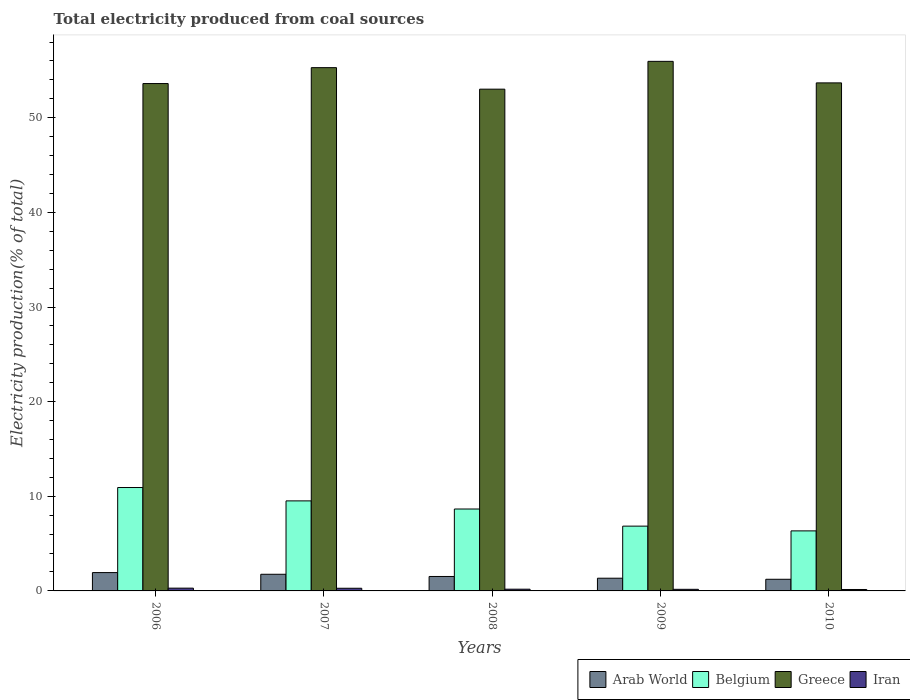How many different coloured bars are there?
Your answer should be very brief. 4. How many groups of bars are there?
Your response must be concise. 5. Are the number of bars per tick equal to the number of legend labels?
Provide a succinct answer. Yes. How many bars are there on the 4th tick from the left?
Your answer should be compact. 4. How many bars are there on the 5th tick from the right?
Ensure brevity in your answer.  4. What is the label of the 3rd group of bars from the left?
Give a very brief answer. 2008. In how many cases, is the number of bars for a given year not equal to the number of legend labels?
Keep it short and to the point. 0. What is the total electricity produced in Iran in 2006?
Offer a terse response. 0.29. Across all years, what is the maximum total electricity produced in Iran?
Provide a succinct answer. 0.29. Across all years, what is the minimum total electricity produced in Iran?
Offer a terse response. 0.15. In which year was the total electricity produced in Iran maximum?
Provide a succinct answer. 2006. What is the total total electricity produced in Greece in the graph?
Make the answer very short. 271.57. What is the difference between the total electricity produced in Arab World in 2007 and that in 2009?
Your response must be concise. 0.42. What is the difference between the total electricity produced in Arab World in 2008 and the total electricity produced in Iran in 2009?
Provide a succinct answer. 1.36. What is the average total electricity produced in Iran per year?
Ensure brevity in your answer.  0.22. In the year 2010, what is the difference between the total electricity produced in Iran and total electricity produced in Greece?
Offer a very short reply. -53.53. What is the ratio of the total electricity produced in Iran in 2008 to that in 2009?
Your answer should be very brief. 1.07. What is the difference between the highest and the second highest total electricity produced in Arab World?
Make the answer very short. 0.18. What is the difference between the highest and the lowest total electricity produced in Iran?
Your response must be concise. 0.14. Is the sum of the total electricity produced in Arab World in 2007 and 2010 greater than the maximum total electricity produced in Belgium across all years?
Provide a succinct answer. No. What does the 3rd bar from the right in 2008 represents?
Offer a terse response. Belgium. Is it the case that in every year, the sum of the total electricity produced in Iran and total electricity produced in Arab World is greater than the total electricity produced in Belgium?
Make the answer very short. No. How many years are there in the graph?
Offer a very short reply. 5. Are the values on the major ticks of Y-axis written in scientific E-notation?
Your answer should be compact. No. Does the graph contain grids?
Keep it short and to the point. No. How many legend labels are there?
Offer a terse response. 4. How are the legend labels stacked?
Provide a succinct answer. Horizontal. What is the title of the graph?
Your answer should be compact. Total electricity produced from coal sources. Does "Least developed countries" appear as one of the legend labels in the graph?
Provide a short and direct response. No. What is the label or title of the X-axis?
Provide a short and direct response. Years. What is the Electricity production(% of total) in Arab World in 2006?
Provide a succinct answer. 1.94. What is the Electricity production(% of total) of Belgium in 2006?
Offer a terse response. 10.93. What is the Electricity production(% of total) of Greece in 2006?
Give a very brief answer. 53.61. What is the Electricity production(% of total) of Iran in 2006?
Offer a very short reply. 0.29. What is the Electricity production(% of total) of Arab World in 2007?
Offer a very short reply. 1.76. What is the Electricity production(% of total) of Belgium in 2007?
Give a very brief answer. 9.51. What is the Electricity production(% of total) in Greece in 2007?
Provide a short and direct response. 55.29. What is the Electricity production(% of total) in Iran in 2007?
Your answer should be very brief. 0.28. What is the Electricity production(% of total) of Arab World in 2008?
Provide a short and direct response. 1.53. What is the Electricity production(% of total) in Belgium in 2008?
Keep it short and to the point. 8.66. What is the Electricity production(% of total) of Greece in 2008?
Offer a terse response. 53.02. What is the Electricity production(% of total) in Iran in 2008?
Make the answer very short. 0.18. What is the Electricity production(% of total) in Arab World in 2009?
Provide a short and direct response. 1.34. What is the Electricity production(% of total) in Belgium in 2009?
Keep it short and to the point. 6.85. What is the Electricity production(% of total) in Greece in 2009?
Your answer should be compact. 55.96. What is the Electricity production(% of total) of Iran in 2009?
Keep it short and to the point. 0.17. What is the Electricity production(% of total) of Arab World in 2010?
Make the answer very short. 1.23. What is the Electricity production(% of total) in Belgium in 2010?
Offer a terse response. 6.34. What is the Electricity production(% of total) of Greece in 2010?
Your answer should be very brief. 53.68. What is the Electricity production(% of total) of Iran in 2010?
Keep it short and to the point. 0.15. Across all years, what is the maximum Electricity production(% of total) of Arab World?
Ensure brevity in your answer.  1.94. Across all years, what is the maximum Electricity production(% of total) in Belgium?
Keep it short and to the point. 10.93. Across all years, what is the maximum Electricity production(% of total) in Greece?
Ensure brevity in your answer.  55.96. Across all years, what is the maximum Electricity production(% of total) of Iran?
Ensure brevity in your answer.  0.29. Across all years, what is the minimum Electricity production(% of total) of Arab World?
Make the answer very short. 1.23. Across all years, what is the minimum Electricity production(% of total) in Belgium?
Make the answer very short. 6.34. Across all years, what is the minimum Electricity production(% of total) in Greece?
Make the answer very short. 53.02. Across all years, what is the minimum Electricity production(% of total) in Iran?
Your answer should be compact. 0.15. What is the total Electricity production(% of total) in Arab World in the graph?
Provide a succinct answer. 7.8. What is the total Electricity production(% of total) in Belgium in the graph?
Keep it short and to the point. 42.29. What is the total Electricity production(% of total) of Greece in the graph?
Ensure brevity in your answer.  271.57. What is the total Electricity production(% of total) in Iran in the graph?
Offer a terse response. 1.08. What is the difference between the Electricity production(% of total) of Arab World in 2006 and that in 2007?
Provide a short and direct response. 0.18. What is the difference between the Electricity production(% of total) of Belgium in 2006 and that in 2007?
Provide a short and direct response. 1.41. What is the difference between the Electricity production(% of total) of Greece in 2006 and that in 2007?
Keep it short and to the point. -1.68. What is the difference between the Electricity production(% of total) in Iran in 2006 and that in 2007?
Offer a very short reply. 0.01. What is the difference between the Electricity production(% of total) of Arab World in 2006 and that in 2008?
Ensure brevity in your answer.  0.41. What is the difference between the Electricity production(% of total) of Belgium in 2006 and that in 2008?
Your answer should be compact. 2.27. What is the difference between the Electricity production(% of total) of Greece in 2006 and that in 2008?
Give a very brief answer. 0.59. What is the difference between the Electricity production(% of total) in Iran in 2006 and that in 2008?
Ensure brevity in your answer.  0.11. What is the difference between the Electricity production(% of total) of Arab World in 2006 and that in 2009?
Make the answer very short. 0.59. What is the difference between the Electricity production(% of total) in Belgium in 2006 and that in 2009?
Your answer should be compact. 4.08. What is the difference between the Electricity production(% of total) of Greece in 2006 and that in 2009?
Ensure brevity in your answer.  -2.35. What is the difference between the Electricity production(% of total) of Iran in 2006 and that in 2009?
Make the answer very short. 0.12. What is the difference between the Electricity production(% of total) of Arab World in 2006 and that in 2010?
Offer a terse response. 0.71. What is the difference between the Electricity production(% of total) in Belgium in 2006 and that in 2010?
Your answer should be very brief. 4.58. What is the difference between the Electricity production(% of total) of Greece in 2006 and that in 2010?
Provide a succinct answer. -0.07. What is the difference between the Electricity production(% of total) in Iran in 2006 and that in 2010?
Provide a short and direct response. 0.14. What is the difference between the Electricity production(% of total) in Arab World in 2007 and that in 2008?
Your answer should be compact. 0.23. What is the difference between the Electricity production(% of total) of Belgium in 2007 and that in 2008?
Make the answer very short. 0.86. What is the difference between the Electricity production(% of total) of Greece in 2007 and that in 2008?
Keep it short and to the point. 2.27. What is the difference between the Electricity production(% of total) in Iran in 2007 and that in 2008?
Give a very brief answer. 0.1. What is the difference between the Electricity production(% of total) of Arab World in 2007 and that in 2009?
Make the answer very short. 0.42. What is the difference between the Electricity production(% of total) in Belgium in 2007 and that in 2009?
Make the answer very short. 2.67. What is the difference between the Electricity production(% of total) of Greece in 2007 and that in 2009?
Offer a very short reply. -0.66. What is the difference between the Electricity production(% of total) of Iran in 2007 and that in 2009?
Provide a short and direct response. 0.11. What is the difference between the Electricity production(% of total) of Arab World in 2007 and that in 2010?
Provide a succinct answer. 0.53. What is the difference between the Electricity production(% of total) of Belgium in 2007 and that in 2010?
Your answer should be compact. 3.17. What is the difference between the Electricity production(% of total) of Greece in 2007 and that in 2010?
Make the answer very short. 1.61. What is the difference between the Electricity production(% of total) of Iran in 2007 and that in 2010?
Provide a succinct answer. 0.13. What is the difference between the Electricity production(% of total) in Arab World in 2008 and that in 2009?
Give a very brief answer. 0.18. What is the difference between the Electricity production(% of total) of Belgium in 2008 and that in 2009?
Offer a terse response. 1.81. What is the difference between the Electricity production(% of total) in Greece in 2008 and that in 2009?
Provide a succinct answer. -2.94. What is the difference between the Electricity production(% of total) in Iran in 2008 and that in 2009?
Provide a succinct answer. 0.01. What is the difference between the Electricity production(% of total) of Arab World in 2008 and that in 2010?
Your response must be concise. 0.3. What is the difference between the Electricity production(% of total) in Belgium in 2008 and that in 2010?
Make the answer very short. 2.31. What is the difference between the Electricity production(% of total) in Greece in 2008 and that in 2010?
Provide a succinct answer. -0.66. What is the difference between the Electricity production(% of total) in Iran in 2008 and that in 2010?
Offer a terse response. 0.03. What is the difference between the Electricity production(% of total) in Arab World in 2009 and that in 2010?
Make the answer very short. 0.11. What is the difference between the Electricity production(% of total) in Belgium in 2009 and that in 2010?
Give a very brief answer. 0.5. What is the difference between the Electricity production(% of total) in Greece in 2009 and that in 2010?
Offer a very short reply. 2.28. What is the difference between the Electricity production(% of total) of Iran in 2009 and that in 2010?
Your answer should be very brief. 0.02. What is the difference between the Electricity production(% of total) in Arab World in 2006 and the Electricity production(% of total) in Belgium in 2007?
Your answer should be compact. -7.58. What is the difference between the Electricity production(% of total) of Arab World in 2006 and the Electricity production(% of total) of Greece in 2007?
Your response must be concise. -53.36. What is the difference between the Electricity production(% of total) in Arab World in 2006 and the Electricity production(% of total) in Iran in 2007?
Make the answer very short. 1.66. What is the difference between the Electricity production(% of total) of Belgium in 2006 and the Electricity production(% of total) of Greece in 2007?
Your response must be concise. -44.37. What is the difference between the Electricity production(% of total) of Belgium in 2006 and the Electricity production(% of total) of Iran in 2007?
Offer a very short reply. 10.64. What is the difference between the Electricity production(% of total) in Greece in 2006 and the Electricity production(% of total) in Iran in 2007?
Provide a succinct answer. 53.33. What is the difference between the Electricity production(% of total) of Arab World in 2006 and the Electricity production(% of total) of Belgium in 2008?
Your answer should be compact. -6.72. What is the difference between the Electricity production(% of total) in Arab World in 2006 and the Electricity production(% of total) in Greece in 2008?
Give a very brief answer. -51.08. What is the difference between the Electricity production(% of total) of Arab World in 2006 and the Electricity production(% of total) of Iran in 2008?
Make the answer very short. 1.76. What is the difference between the Electricity production(% of total) of Belgium in 2006 and the Electricity production(% of total) of Greece in 2008?
Offer a terse response. -42.09. What is the difference between the Electricity production(% of total) in Belgium in 2006 and the Electricity production(% of total) in Iran in 2008?
Your response must be concise. 10.74. What is the difference between the Electricity production(% of total) in Greece in 2006 and the Electricity production(% of total) in Iran in 2008?
Provide a short and direct response. 53.43. What is the difference between the Electricity production(% of total) of Arab World in 2006 and the Electricity production(% of total) of Belgium in 2009?
Your answer should be compact. -4.91. What is the difference between the Electricity production(% of total) in Arab World in 2006 and the Electricity production(% of total) in Greece in 2009?
Your response must be concise. -54.02. What is the difference between the Electricity production(% of total) of Arab World in 2006 and the Electricity production(% of total) of Iran in 2009?
Give a very brief answer. 1.77. What is the difference between the Electricity production(% of total) in Belgium in 2006 and the Electricity production(% of total) in Greece in 2009?
Offer a very short reply. -45.03. What is the difference between the Electricity production(% of total) in Belgium in 2006 and the Electricity production(% of total) in Iran in 2009?
Give a very brief answer. 10.76. What is the difference between the Electricity production(% of total) in Greece in 2006 and the Electricity production(% of total) in Iran in 2009?
Offer a terse response. 53.44. What is the difference between the Electricity production(% of total) of Arab World in 2006 and the Electricity production(% of total) of Belgium in 2010?
Your answer should be very brief. -4.41. What is the difference between the Electricity production(% of total) in Arab World in 2006 and the Electricity production(% of total) in Greece in 2010?
Keep it short and to the point. -51.75. What is the difference between the Electricity production(% of total) in Arab World in 2006 and the Electricity production(% of total) in Iran in 2010?
Make the answer very short. 1.79. What is the difference between the Electricity production(% of total) in Belgium in 2006 and the Electricity production(% of total) in Greece in 2010?
Offer a very short reply. -42.76. What is the difference between the Electricity production(% of total) in Belgium in 2006 and the Electricity production(% of total) in Iran in 2010?
Provide a short and direct response. 10.77. What is the difference between the Electricity production(% of total) in Greece in 2006 and the Electricity production(% of total) in Iran in 2010?
Keep it short and to the point. 53.46. What is the difference between the Electricity production(% of total) in Arab World in 2007 and the Electricity production(% of total) in Belgium in 2008?
Ensure brevity in your answer.  -6.9. What is the difference between the Electricity production(% of total) in Arab World in 2007 and the Electricity production(% of total) in Greece in 2008?
Offer a terse response. -51.26. What is the difference between the Electricity production(% of total) in Arab World in 2007 and the Electricity production(% of total) in Iran in 2008?
Give a very brief answer. 1.58. What is the difference between the Electricity production(% of total) in Belgium in 2007 and the Electricity production(% of total) in Greece in 2008?
Offer a terse response. -43.51. What is the difference between the Electricity production(% of total) in Belgium in 2007 and the Electricity production(% of total) in Iran in 2008?
Offer a terse response. 9.33. What is the difference between the Electricity production(% of total) in Greece in 2007 and the Electricity production(% of total) in Iran in 2008?
Offer a very short reply. 55.11. What is the difference between the Electricity production(% of total) in Arab World in 2007 and the Electricity production(% of total) in Belgium in 2009?
Provide a succinct answer. -5.09. What is the difference between the Electricity production(% of total) of Arab World in 2007 and the Electricity production(% of total) of Greece in 2009?
Your response must be concise. -54.2. What is the difference between the Electricity production(% of total) in Arab World in 2007 and the Electricity production(% of total) in Iran in 2009?
Provide a short and direct response. 1.59. What is the difference between the Electricity production(% of total) in Belgium in 2007 and the Electricity production(% of total) in Greece in 2009?
Offer a very short reply. -46.45. What is the difference between the Electricity production(% of total) in Belgium in 2007 and the Electricity production(% of total) in Iran in 2009?
Your answer should be very brief. 9.34. What is the difference between the Electricity production(% of total) of Greece in 2007 and the Electricity production(% of total) of Iran in 2009?
Provide a succinct answer. 55.13. What is the difference between the Electricity production(% of total) of Arab World in 2007 and the Electricity production(% of total) of Belgium in 2010?
Your response must be concise. -4.58. What is the difference between the Electricity production(% of total) in Arab World in 2007 and the Electricity production(% of total) in Greece in 2010?
Ensure brevity in your answer.  -51.92. What is the difference between the Electricity production(% of total) of Arab World in 2007 and the Electricity production(% of total) of Iran in 2010?
Make the answer very short. 1.61. What is the difference between the Electricity production(% of total) of Belgium in 2007 and the Electricity production(% of total) of Greece in 2010?
Keep it short and to the point. -44.17. What is the difference between the Electricity production(% of total) of Belgium in 2007 and the Electricity production(% of total) of Iran in 2010?
Provide a succinct answer. 9.36. What is the difference between the Electricity production(% of total) of Greece in 2007 and the Electricity production(% of total) of Iran in 2010?
Give a very brief answer. 55.14. What is the difference between the Electricity production(% of total) in Arab World in 2008 and the Electricity production(% of total) in Belgium in 2009?
Your answer should be very brief. -5.32. What is the difference between the Electricity production(% of total) in Arab World in 2008 and the Electricity production(% of total) in Greece in 2009?
Keep it short and to the point. -54.43. What is the difference between the Electricity production(% of total) in Arab World in 2008 and the Electricity production(% of total) in Iran in 2009?
Offer a terse response. 1.36. What is the difference between the Electricity production(% of total) of Belgium in 2008 and the Electricity production(% of total) of Greece in 2009?
Keep it short and to the point. -47.3. What is the difference between the Electricity production(% of total) of Belgium in 2008 and the Electricity production(% of total) of Iran in 2009?
Your answer should be very brief. 8.49. What is the difference between the Electricity production(% of total) in Greece in 2008 and the Electricity production(% of total) in Iran in 2009?
Ensure brevity in your answer.  52.85. What is the difference between the Electricity production(% of total) of Arab World in 2008 and the Electricity production(% of total) of Belgium in 2010?
Provide a short and direct response. -4.82. What is the difference between the Electricity production(% of total) in Arab World in 2008 and the Electricity production(% of total) in Greece in 2010?
Your answer should be very brief. -52.16. What is the difference between the Electricity production(% of total) of Arab World in 2008 and the Electricity production(% of total) of Iran in 2010?
Your response must be concise. 1.38. What is the difference between the Electricity production(% of total) in Belgium in 2008 and the Electricity production(% of total) in Greece in 2010?
Provide a succinct answer. -45.03. What is the difference between the Electricity production(% of total) of Belgium in 2008 and the Electricity production(% of total) of Iran in 2010?
Provide a short and direct response. 8.5. What is the difference between the Electricity production(% of total) in Greece in 2008 and the Electricity production(% of total) in Iran in 2010?
Provide a succinct answer. 52.87. What is the difference between the Electricity production(% of total) of Arab World in 2009 and the Electricity production(% of total) of Belgium in 2010?
Provide a short and direct response. -5. What is the difference between the Electricity production(% of total) of Arab World in 2009 and the Electricity production(% of total) of Greece in 2010?
Make the answer very short. -52.34. What is the difference between the Electricity production(% of total) of Arab World in 2009 and the Electricity production(% of total) of Iran in 2010?
Ensure brevity in your answer.  1.19. What is the difference between the Electricity production(% of total) in Belgium in 2009 and the Electricity production(% of total) in Greece in 2010?
Keep it short and to the point. -46.84. What is the difference between the Electricity production(% of total) of Belgium in 2009 and the Electricity production(% of total) of Iran in 2010?
Your answer should be very brief. 6.69. What is the difference between the Electricity production(% of total) in Greece in 2009 and the Electricity production(% of total) in Iran in 2010?
Offer a terse response. 55.81. What is the average Electricity production(% of total) of Arab World per year?
Your response must be concise. 1.56. What is the average Electricity production(% of total) of Belgium per year?
Offer a terse response. 8.46. What is the average Electricity production(% of total) of Greece per year?
Your answer should be compact. 54.31. What is the average Electricity production(% of total) of Iran per year?
Provide a succinct answer. 0.22. In the year 2006, what is the difference between the Electricity production(% of total) in Arab World and Electricity production(% of total) in Belgium?
Make the answer very short. -8.99. In the year 2006, what is the difference between the Electricity production(% of total) of Arab World and Electricity production(% of total) of Greece?
Keep it short and to the point. -51.68. In the year 2006, what is the difference between the Electricity production(% of total) of Arab World and Electricity production(% of total) of Iran?
Your response must be concise. 1.65. In the year 2006, what is the difference between the Electricity production(% of total) of Belgium and Electricity production(% of total) of Greece?
Offer a very short reply. -42.69. In the year 2006, what is the difference between the Electricity production(% of total) in Belgium and Electricity production(% of total) in Iran?
Provide a short and direct response. 10.63. In the year 2006, what is the difference between the Electricity production(% of total) of Greece and Electricity production(% of total) of Iran?
Make the answer very short. 53.32. In the year 2007, what is the difference between the Electricity production(% of total) in Arab World and Electricity production(% of total) in Belgium?
Ensure brevity in your answer.  -7.75. In the year 2007, what is the difference between the Electricity production(% of total) in Arab World and Electricity production(% of total) in Greece?
Offer a terse response. -53.54. In the year 2007, what is the difference between the Electricity production(% of total) of Arab World and Electricity production(% of total) of Iran?
Your answer should be very brief. 1.48. In the year 2007, what is the difference between the Electricity production(% of total) of Belgium and Electricity production(% of total) of Greece?
Provide a short and direct response. -45.78. In the year 2007, what is the difference between the Electricity production(% of total) of Belgium and Electricity production(% of total) of Iran?
Make the answer very short. 9.23. In the year 2007, what is the difference between the Electricity production(% of total) in Greece and Electricity production(% of total) in Iran?
Make the answer very short. 55.01. In the year 2008, what is the difference between the Electricity production(% of total) in Arab World and Electricity production(% of total) in Belgium?
Provide a short and direct response. -7.13. In the year 2008, what is the difference between the Electricity production(% of total) of Arab World and Electricity production(% of total) of Greece?
Give a very brief answer. -51.49. In the year 2008, what is the difference between the Electricity production(% of total) in Arab World and Electricity production(% of total) in Iran?
Make the answer very short. 1.35. In the year 2008, what is the difference between the Electricity production(% of total) of Belgium and Electricity production(% of total) of Greece?
Give a very brief answer. -44.36. In the year 2008, what is the difference between the Electricity production(% of total) in Belgium and Electricity production(% of total) in Iran?
Provide a succinct answer. 8.47. In the year 2008, what is the difference between the Electricity production(% of total) of Greece and Electricity production(% of total) of Iran?
Your response must be concise. 52.84. In the year 2009, what is the difference between the Electricity production(% of total) of Arab World and Electricity production(% of total) of Belgium?
Provide a succinct answer. -5.5. In the year 2009, what is the difference between the Electricity production(% of total) of Arab World and Electricity production(% of total) of Greece?
Your answer should be compact. -54.62. In the year 2009, what is the difference between the Electricity production(% of total) in Arab World and Electricity production(% of total) in Iran?
Provide a succinct answer. 1.17. In the year 2009, what is the difference between the Electricity production(% of total) of Belgium and Electricity production(% of total) of Greece?
Provide a succinct answer. -49.11. In the year 2009, what is the difference between the Electricity production(% of total) in Belgium and Electricity production(% of total) in Iran?
Your answer should be very brief. 6.68. In the year 2009, what is the difference between the Electricity production(% of total) in Greece and Electricity production(% of total) in Iran?
Your response must be concise. 55.79. In the year 2010, what is the difference between the Electricity production(% of total) in Arab World and Electricity production(% of total) in Belgium?
Ensure brevity in your answer.  -5.11. In the year 2010, what is the difference between the Electricity production(% of total) of Arab World and Electricity production(% of total) of Greece?
Your answer should be very brief. -52.45. In the year 2010, what is the difference between the Electricity production(% of total) of Arab World and Electricity production(% of total) of Iran?
Ensure brevity in your answer.  1.08. In the year 2010, what is the difference between the Electricity production(% of total) in Belgium and Electricity production(% of total) in Greece?
Keep it short and to the point. -47.34. In the year 2010, what is the difference between the Electricity production(% of total) of Belgium and Electricity production(% of total) of Iran?
Provide a succinct answer. 6.19. In the year 2010, what is the difference between the Electricity production(% of total) in Greece and Electricity production(% of total) in Iran?
Give a very brief answer. 53.53. What is the ratio of the Electricity production(% of total) of Arab World in 2006 to that in 2007?
Offer a very short reply. 1.1. What is the ratio of the Electricity production(% of total) in Belgium in 2006 to that in 2007?
Your answer should be very brief. 1.15. What is the ratio of the Electricity production(% of total) in Greece in 2006 to that in 2007?
Provide a succinct answer. 0.97. What is the ratio of the Electricity production(% of total) of Iran in 2006 to that in 2007?
Your answer should be very brief. 1.04. What is the ratio of the Electricity production(% of total) of Arab World in 2006 to that in 2008?
Provide a succinct answer. 1.27. What is the ratio of the Electricity production(% of total) of Belgium in 2006 to that in 2008?
Your response must be concise. 1.26. What is the ratio of the Electricity production(% of total) of Greece in 2006 to that in 2008?
Give a very brief answer. 1.01. What is the ratio of the Electricity production(% of total) of Iran in 2006 to that in 2008?
Provide a succinct answer. 1.61. What is the ratio of the Electricity production(% of total) in Arab World in 2006 to that in 2009?
Provide a succinct answer. 1.44. What is the ratio of the Electricity production(% of total) of Belgium in 2006 to that in 2009?
Your answer should be compact. 1.6. What is the ratio of the Electricity production(% of total) of Greece in 2006 to that in 2009?
Offer a very short reply. 0.96. What is the ratio of the Electricity production(% of total) of Iran in 2006 to that in 2009?
Provide a short and direct response. 1.72. What is the ratio of the Electricity production(% of total) of Arab World in 2006 to that in 2010?
Your answer should be very brief. 1.57. What is the ratio of the Electricity production(% of total) in Belgium in 2006 to that in 2010?
Your response must be concise. 1.72. What is the ratio of the Electricity production(% of total) in Greece in 2006 to that in 2010?
Keep it short and to the point. 1. What is the ratio of the Electricity production(% of total) of Iran in 2006 to that in 2010?
Provide a succinct answer. 1.93. What is the ratio of the Electricity production(% of total) in Arab World in 2007 to that in 2008?
Ensure brevity in your answer.  1.15. What is the ratio of the Electricity production(% of total) in Belgium in 2007 to that in 2008?
Provide a succinct answer. 1.1. What is the ratio of the Electricity production(% of total) of Greece in 2007 to that in 2008?
Your answer should be very brief. 1.04. What is the ratio of the Electricity production(% of total) in Iran in 2007 to that in 2008?
Offer a very short reply. 1.55. What is the ratio of the Electricity production(% of total) in Arab World in 2007 to that in 2009?
Your answer should be very brief. 1.31. What is the ratio of the Electricity production(% of total) in Belgium in 2007 to that in 2009?
Ensure brevity in your answer.  1.39. What is the ratio of the Electricity production(% of total) in Greece in 2007 to that in 2009?
Make the answer very short. 0.99. What is the ratio of the Electricity production(% of total) of Iran in 2007 to that in 2009?
Ensure brevity in your answer.  1.66. What is the ratio of the Electricity production(% of total) in Arab World in 2007 to that in 2010?
Your response must be concise. 1.43. What is the ratio of the Electricity production(% of total) of Belgium in 2007 to that in 2010?
Make the answer very short. 1.5. What is the ratio of the Electricity production(% of total) in Iran in 2007 to that in 2010?
Keep it short and to the point. 1.86. What is the ratio of the Electricity production(% of total) in Arab World in 2008 to that in 2009?
Keep it short and to the point. 1.14. What is the ratio of the Electricity production(% of total) in Belgium in 2008 to that in 2009?
Keep it short and to the point. 1.26. What is the ratio of the Electricity production(% of total) of Greece in 2008 to that in 2009?
Offer a very short reply. 0.95. What is the ratio of the Electricity production(% of total) in Iran in 2008 to that in 2009?
Ensure brevity in your answer.  1.07. What is the ratio of the Electricity production(% of total) of Arab World in 2008 to that in 2010?
Provide a succinct answer. 1.24. What is the ratio of the Electricity production(% of total) in Belgium in 2008 to that in 2010?
Your response must be concise. 1.36. What is the ratio of the Electricity production(% of total) of Greece in 2008 to that in 2010?
Give a very brief answer. 0.99. What is the ratio of the Electricity production(% of total) of Iran in 2008 to that in 2010?
Provide a short and direct response. 1.2. What is the ratio of the Electricity production(% of total) in Arab World in 2009 to that in 2010?
Give a very brief answer. 1.09. What is the ratio of the Electricity production(% of total) in Belgium in 2009 to that in 2010?
Provide a succinct answer. 1.08. What is the ratio of the Electricity production(% of total) of Greece in 2009 to that in 2010?
Offer a very short reply. 1.04. What is the ratio of the Electricity production(% of total) of Iran in 2009 to that in 2010?
Offer a terse response. 1.12. What is the difference between the highest and the second highest Electricity production(% of total) in Arab World?
Ensure brevity in your answer.  0.18. What is the difference between the highest and the second highest Electricity production(% of total) in Belgium?
Provide a short and direct response. 1.41. What is the difference between the highest and the second highest Electricity production(% of total) in Greece?
Provide a succinct answer. 0.66. What is the difference between the highest and the second highest Electricity production(% of total) of Iran?
Offer a terse response. 0.01. What is the difference between the highest and the lowest Electricity production(% of total) of Arab World?
Provide a short and direct response. 0.71. What is the difference between the highest and the lowest Electricity production(% of total) of Belgium?
Keep it short and to the point. 4.58. What is the difference between the highest and the lowest Electricity production(% of total) of Greece?
Your response must be concise. 2.94. What is the difference between the highest and the lowest Electricity production(% of total) of Iran?
Your answer should be compact. 0.14. 